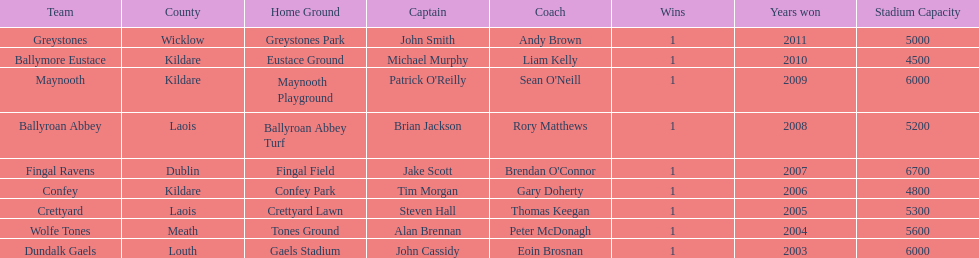Which is the first team from the chart Greystones. I'm looking to parse the entire table for insights. Could you assist me with that? {'header': ['Team', 'County', 'Home Ground', 'Captain', 'Coach', 'Wins', 'Years won', 'Stadium Capacity'], 'rows': [['Greystones', 'Wicklow', 'Greystones Park', 'John Smith', 'Andy Brown', '1', '2011', '5000'], ['Ballymore Eustace', 'Kildare', 'Eustace Ground', 'Michael Murphy', 'Liam Kelly', '1', '2010', '4500'], ['Maynooth', 'Kildare', 'Maynooth Playground', "Patrick O'Reilly", "Sean O'Neill", '1', '2009', '6000'], ['Ballyroan Abbey', 'Laois', 'Ballyroan Abbey Turf', 'Brian Jackson', 'Rory Matthews', '1', '2008', '5200'], ['Fingal Ravens', 'Dublin', 'Fingal Field', 'Jake Scott', "Brendan O'Connor", '1', '2007', '6700'], ['Confey', 'Kildare', 'Confey Park', 'Tim Morgan', 'Gary Doherty', '1', '2006', '4800'], ['Crettyard', 'Laois', 'Crettyard Lawn', 'Steven Hall', 'Thomas Keegan', '1', '2005', '5300'], ['Wolfe Tones', 'Meath', 'Tones Ground', 'Alan Brennan', 'Peter McDonagh', '1', '2004', '5600'], ['Dundalk Gaels', 'Louth', 'Gaels Stadium', 'John Cassidy', 'Eoin Brosnan', '1', '2003', '6000']]} 